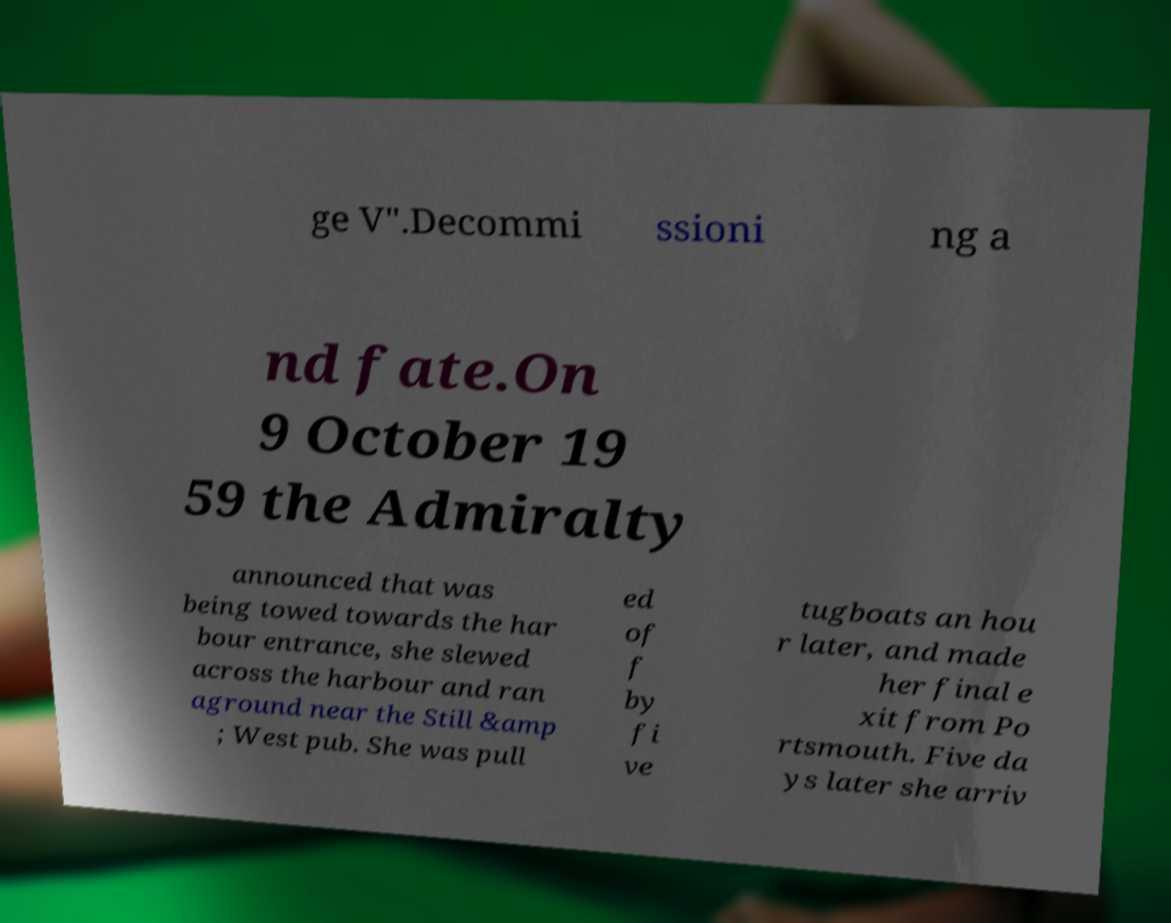Can you read and provide the text displayed in the image?This photo seems to have some interesting text. Can you extract and type it out for me? ge V".Decommi ssioni ng a nd fate.On 9 October 19 59 the Admiralty announced that was being towed towards the har bour entrance, she slewed across the harbour and ran aground near the Still &amp ; West pub. She was pull ed of f by fi ve tugboats an hou r later, and made her final e xit from Po rtsmouth. Five da ys later she arriv 